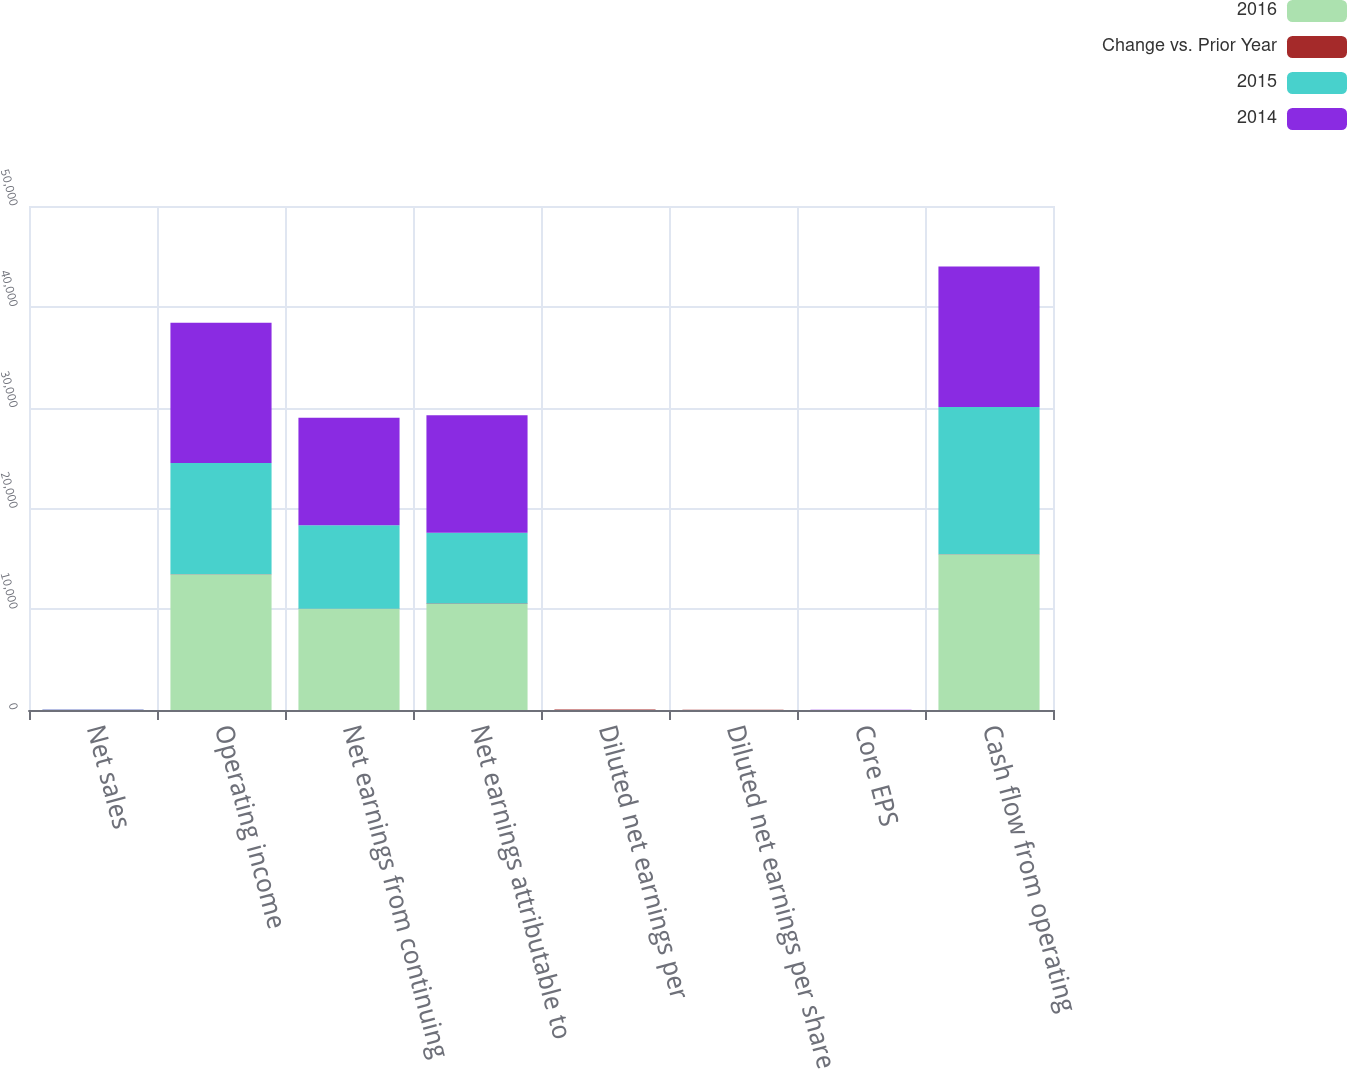<chart> <loc_0><loc_0><loc_500><loc_500><stacked_bar_chart><ecel><fcel>Net sales<fcel>Operating income<fcel>Net earnings from continuing<fcel>Net earnings attributable to<fcel>Diluted net earnings per<fcel>Diluted net earnings per share<fcel>Core EPS<fcel>Cash flow from operating<nl><fcel>2016<fcel>23<fcel>13441<fcel>10027<fcel>10508<fcel>3.69<fcel>3.49<fcel>3.67<fcel>15435<nl><fcel>Change vs. Prior Year<fcel>8<fcel>22<fcel>21<fcel>49<fcel>51<fcel>23<fcel>2<fcel>6<nl><fcel>2015<fcel>23<fcel>11049<fcel>8287<fcel>7036<fcel>2.44<fcel>2.84<fcel>3.76<fcel>14608<nl><fcel>2014<fcel>23<fcel>13910<fcel>10658<fcel>11643<fcel>4.01<fcel>3.63<fcel>3.85<fcel>13958<nl></chart> 